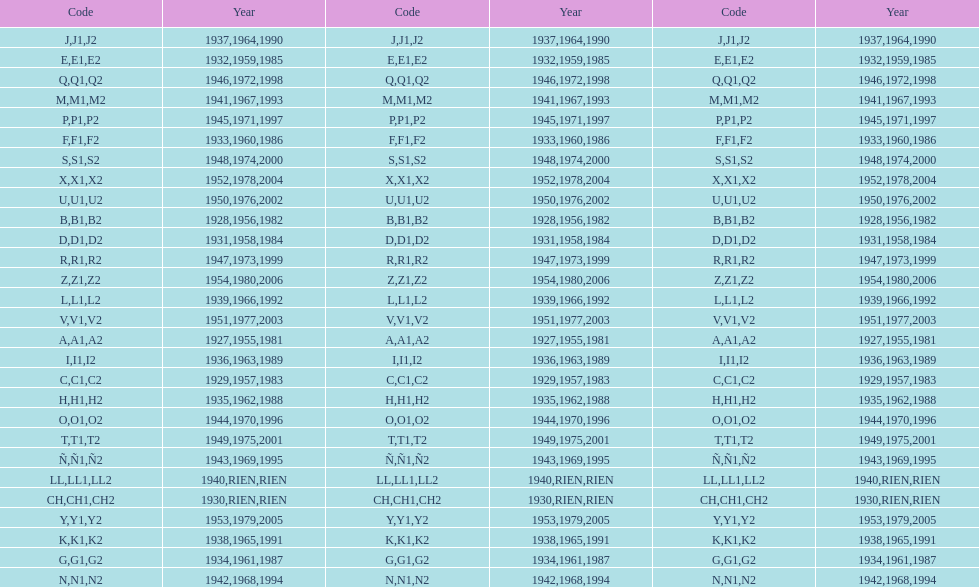What was the lowest year stamped? 1927. 